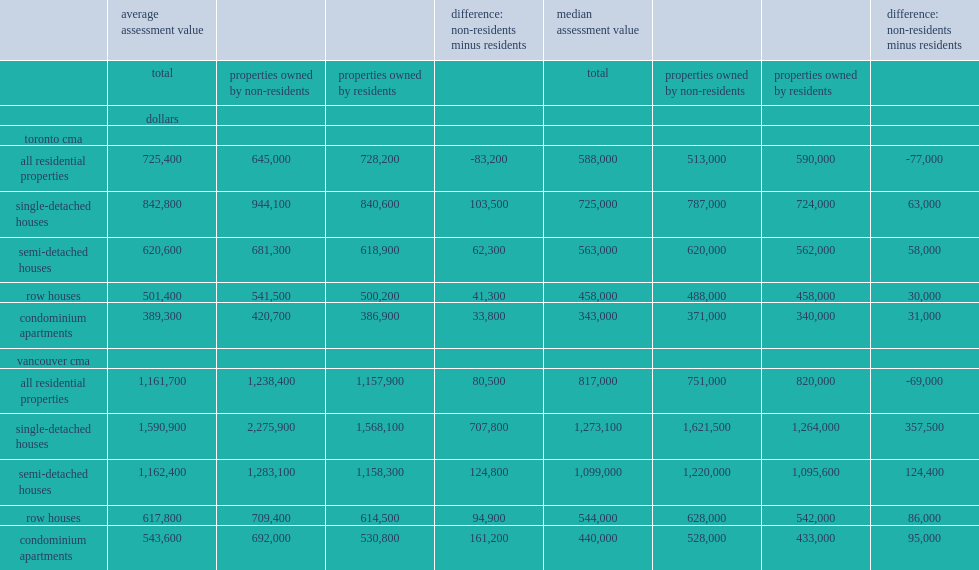How many dollars was the average value of all residential assets in vancouver owned by non-residents higher than the average for canadian residents? 80500.0. For the vancouver cma as a whole, how many dollars was the average value of single-detached houses owned by non-residents higher than the average for residents? 707800.0. What was average market value of single-detached houses owned by non-residents in vancouver? 2275900.0. What was average market value of single-detached houses owned by residents in vancouver? 1568100.0. In the toronto cma, what was the average assessed value of all residential properties owned by non-residents in may 2017? 645000.0. In the toronto cma, how many dollars was the averageassessed value of all residential properties owned by non-residents lower than the average value of all resident-owned properties? 83200. 